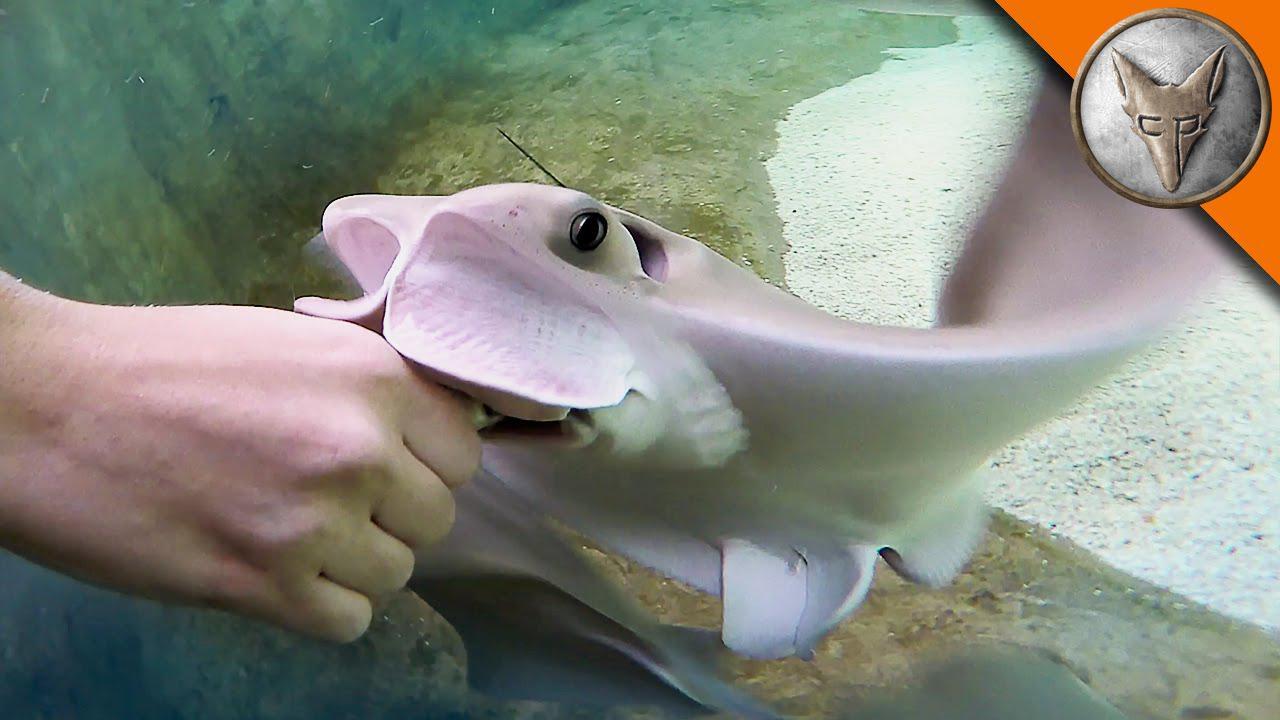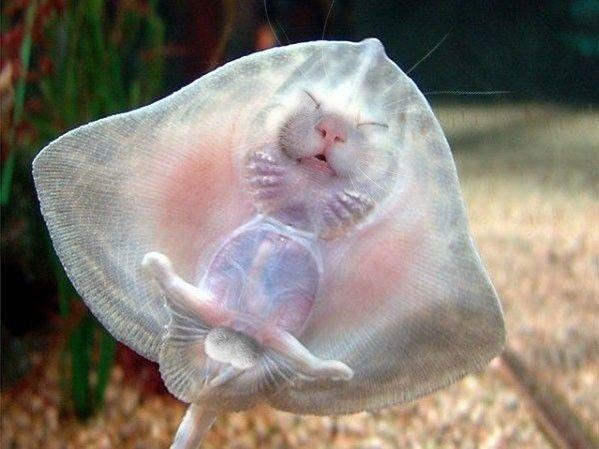The first image is the image on the left, the second image is the image on the right. Analyze the images presented: Is the assertion "In one of the images, a human hand is interacting with a fish." valid? Answer yes or no. Yes. The first image is the image on the left, the second image is the image on the right. Evaluate the accuracy of this statement regarding the images: "A person is hand feeding a marine animal.". Is it true? Answer yes or no. Yes. 